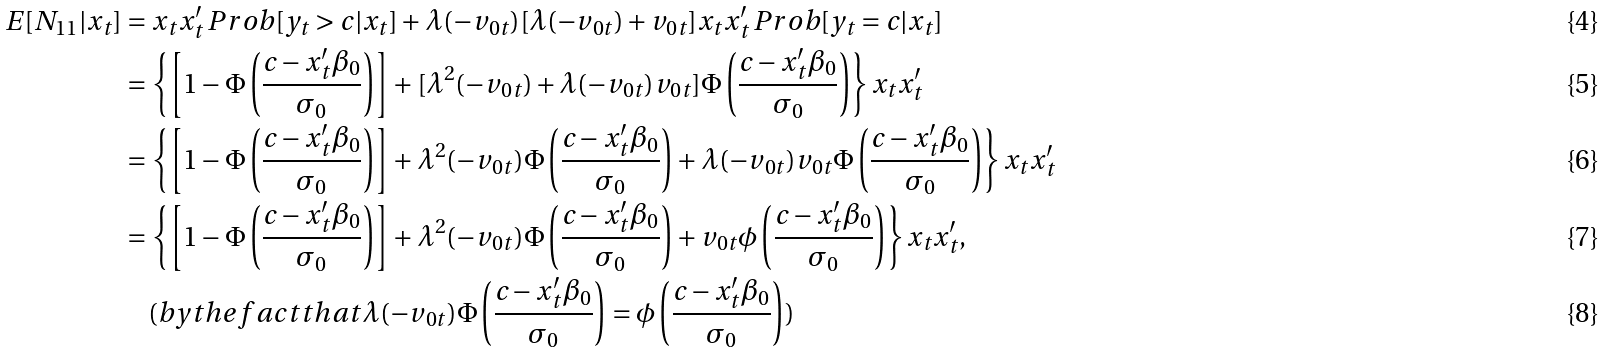<formula> <loc_0><loc_0><loc_500><loc_500>E [ N _ { 1 1 } | x _ { t } ] & = x _ { t } x ^ { \prime } _ { t } \, P r o b [ y _ { t } > c | x _ { t } ] + \lambda ( - v _ { 0 t } ) [ \lambda ( - v _ { 0 t } ) + v _ { 0 t } ] x _ { t } x ^ { \prime } _ { t } \, P r o b [ y _ { t } = c | x _ { t } ] \\ & = \left \{ \left [ 1 - \Phi \left ( \frac { c - x ^ { \prime } _ { t } \beta _ { 0 } } { \sigma _ { 0 } } \right ) \right ] + [ \lambda ^ { 2 } ( - v _ { 0 t } ) + \lambda ( - v _ { 0 t } ) v _ { 0 t } ] \Phi \left ( \frac { c - x ^ { \prime } _ { t } \beta _ { 0 } } { \sigma _ { 0 } } \right ) \right \} x _ { t } x ^ { \prime } _ { t } \\ & = \left \{ \left [ 1 - \Phi \left ( \frac { c - x ^ { \prime } _ { t } \beta _ { 0 } } { \sigma _ { 0 } } \right ) \right ] + \lambda ^ { 2 } ( - v _ { 0 t } ) \Phi \left ( \frac { c - x ^ { \prime } _ { t } \beta _ { 0 } } { \sigma _ { 0 } } \right ) + \lambda ( - v _ { 0 t } ) v _ { 0 t } \Phi \left ( \frac { c - x ^ { \prime } _ { t } \beta _ { 0 } } { \sigma _ { 0 } } \right ) \right \} x _ { t } x ^ { \prime } _ { t } \\ & = \left \{ \left [ 1 - \Phi \left ( \frac { c - x ^ { \prime } _ { t } \beta _ { 0 } } { \sigma _ { 0 } } \right ) \right ] + \lambda ^ { 2 } ( - v _ { 0 t } ) \Phi \left ( \frac { c - x ^ { \prime } _ { t } \beta _ { 0 } } { \sigma _ { 0 } } \right ) + v _ { 0 t } \phi \left ( \frac { c - x ^ { \prime } _ { t } \beta _ { 0 } } { \sigma _ { 0 } } \right ) \right \} x _ { t } x ^ { \prime } _ { t } , \\ & \quad ( b y t h e f a c t t h a t \lambda ( - v _ { 0 t } ) \Phi \left ( \frac { c - x ^ { \prime } _ { t } \beta _ { 0 } } { \sigma _ { 0 } } \right ) = \phi \left ( \frac { c - x ^ { \prime } _ { t } \beta _ { 0 } } { \sigma _ { 0 } } \right ) )</formula> 